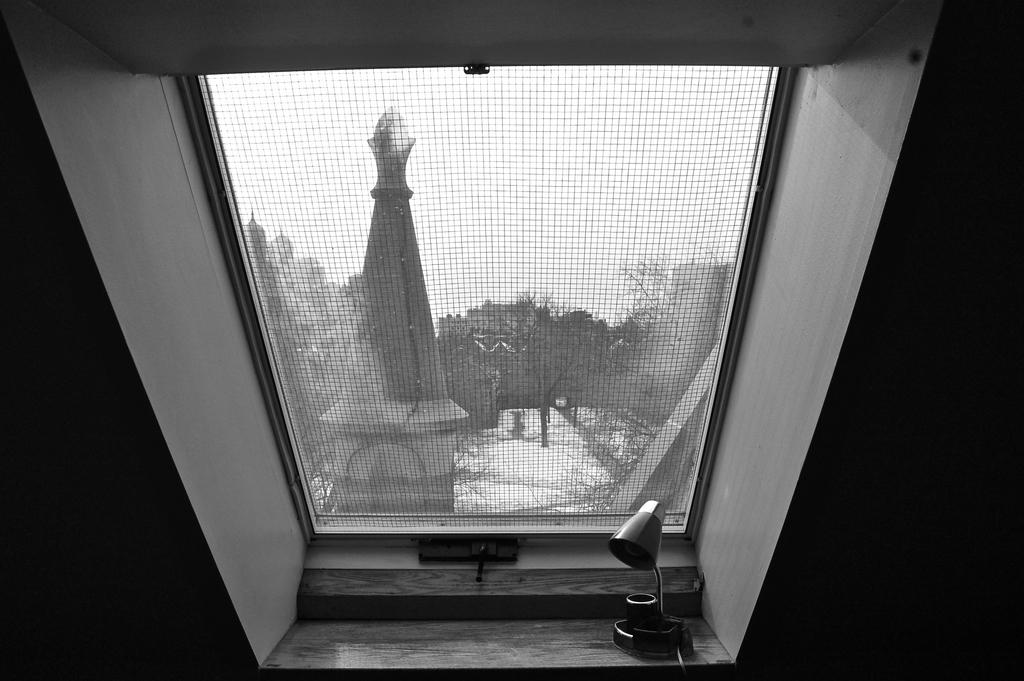What is located near the window in the image? There is an object near the window in the image. What is present on the window in the image? There is a window mesh net in the image. What can be seen outside the window? The sky, trees, and a tower are visible outside the window. What type of joke is being told by the church in the image? There is no church present in the image, so it is not possible to determine if a joke is being told. 